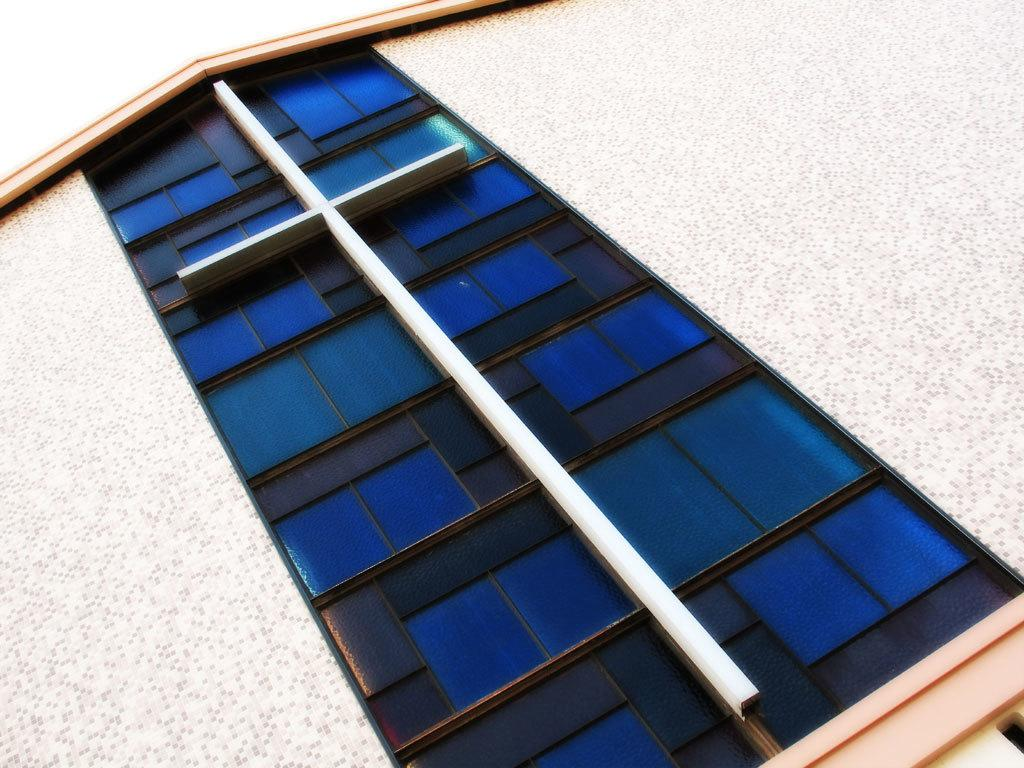What type of structure is present in the image? There is a building in the image. What part of the natural environment is visible in the image? The sky is visible in the image. What color is the orange in the image? There is no orange present in the image. What type of watercraft can be seen in the harbor in the image? There is no harbor or watercraft present in the image. 